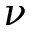<formula> <loc_0><loc_0><loc_500><loc_500>\nu</formula> 